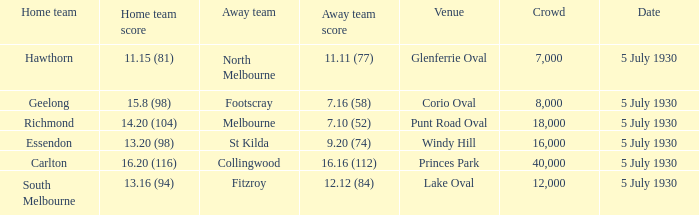What day does the team play at punt road oval? 5 July 1930. 